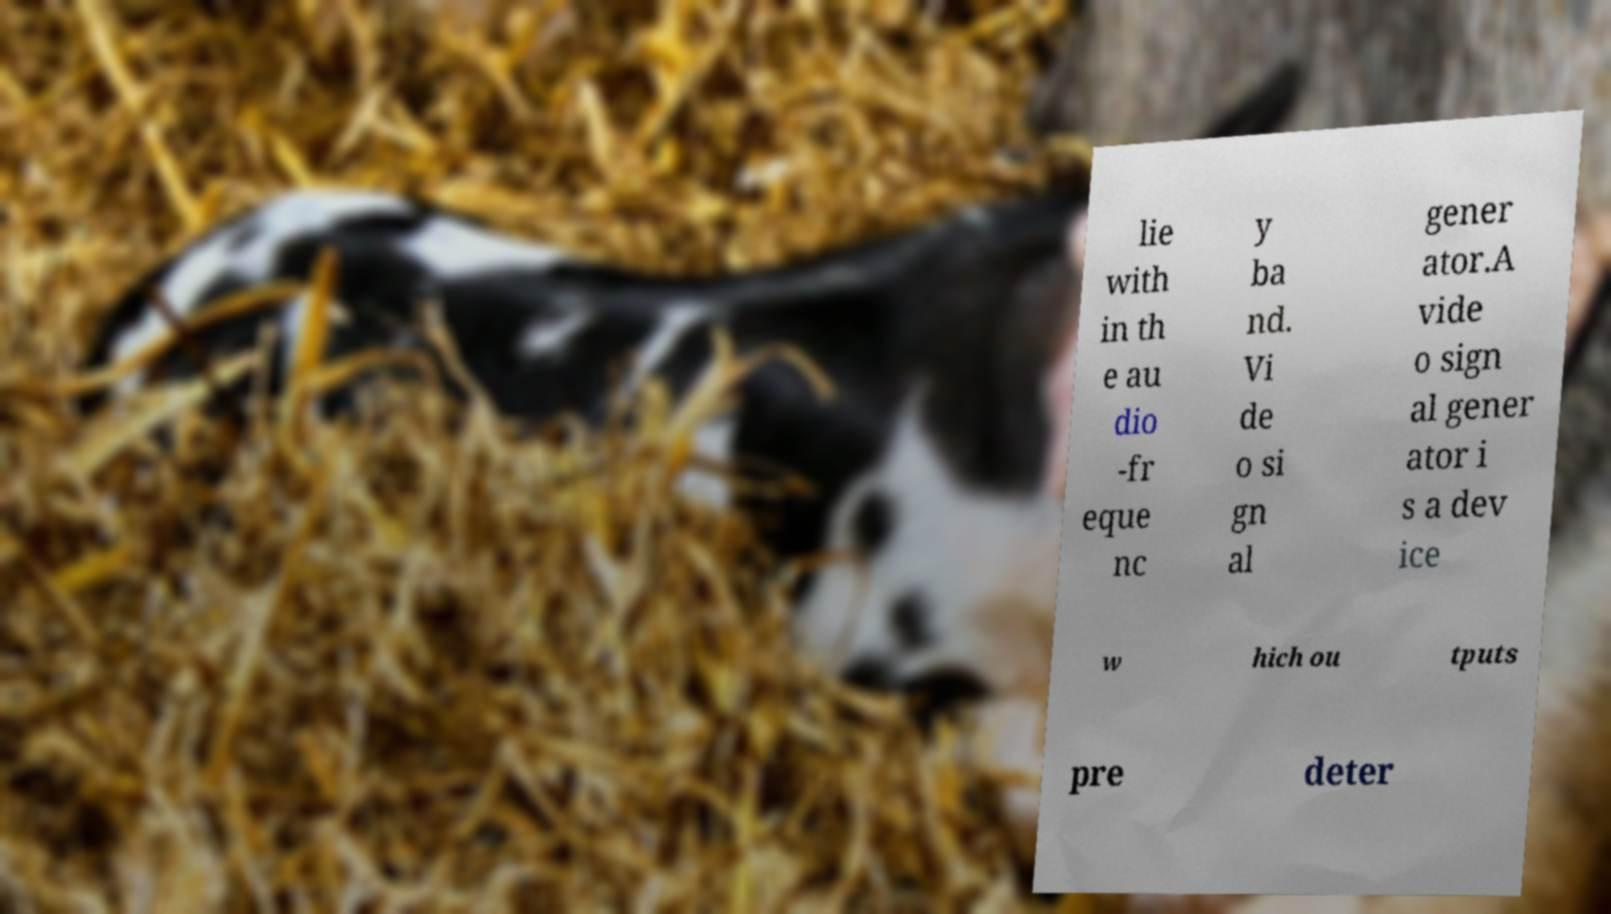There's text embedded in this image that I need extracted. Can you transcribe it verbatim? lie with in th e au dio -fr eque nc y ba nd. Vi de o si gn al gener ator.A vide o sign al gener ator i s a dev ice w hich ou tputs pre deter 